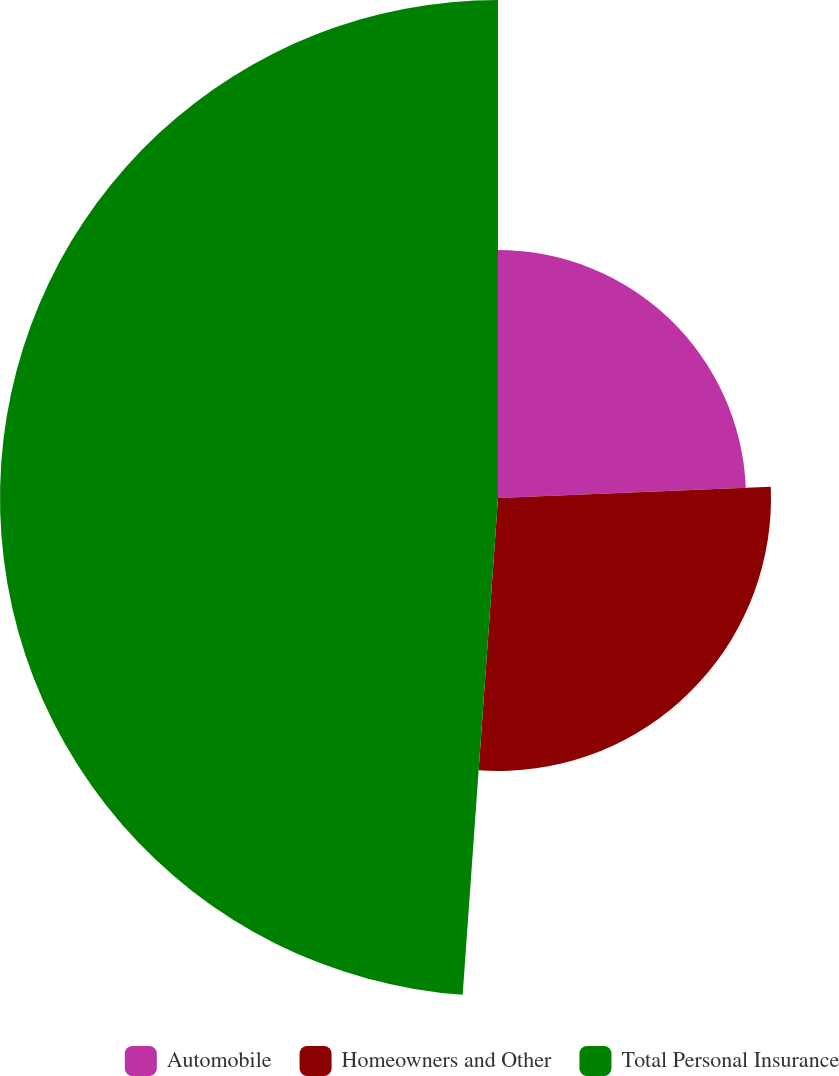Convert chart. <chart><loc_0><loc_0><loc_500><loc_500><pie_chart><fcel>Automobile<fcel>Homeowners and Other<fcel>Total Personal Insurance<nl><fcel>24.34%<fcel>26.79%<fcel>48.87%<nl></chart> 